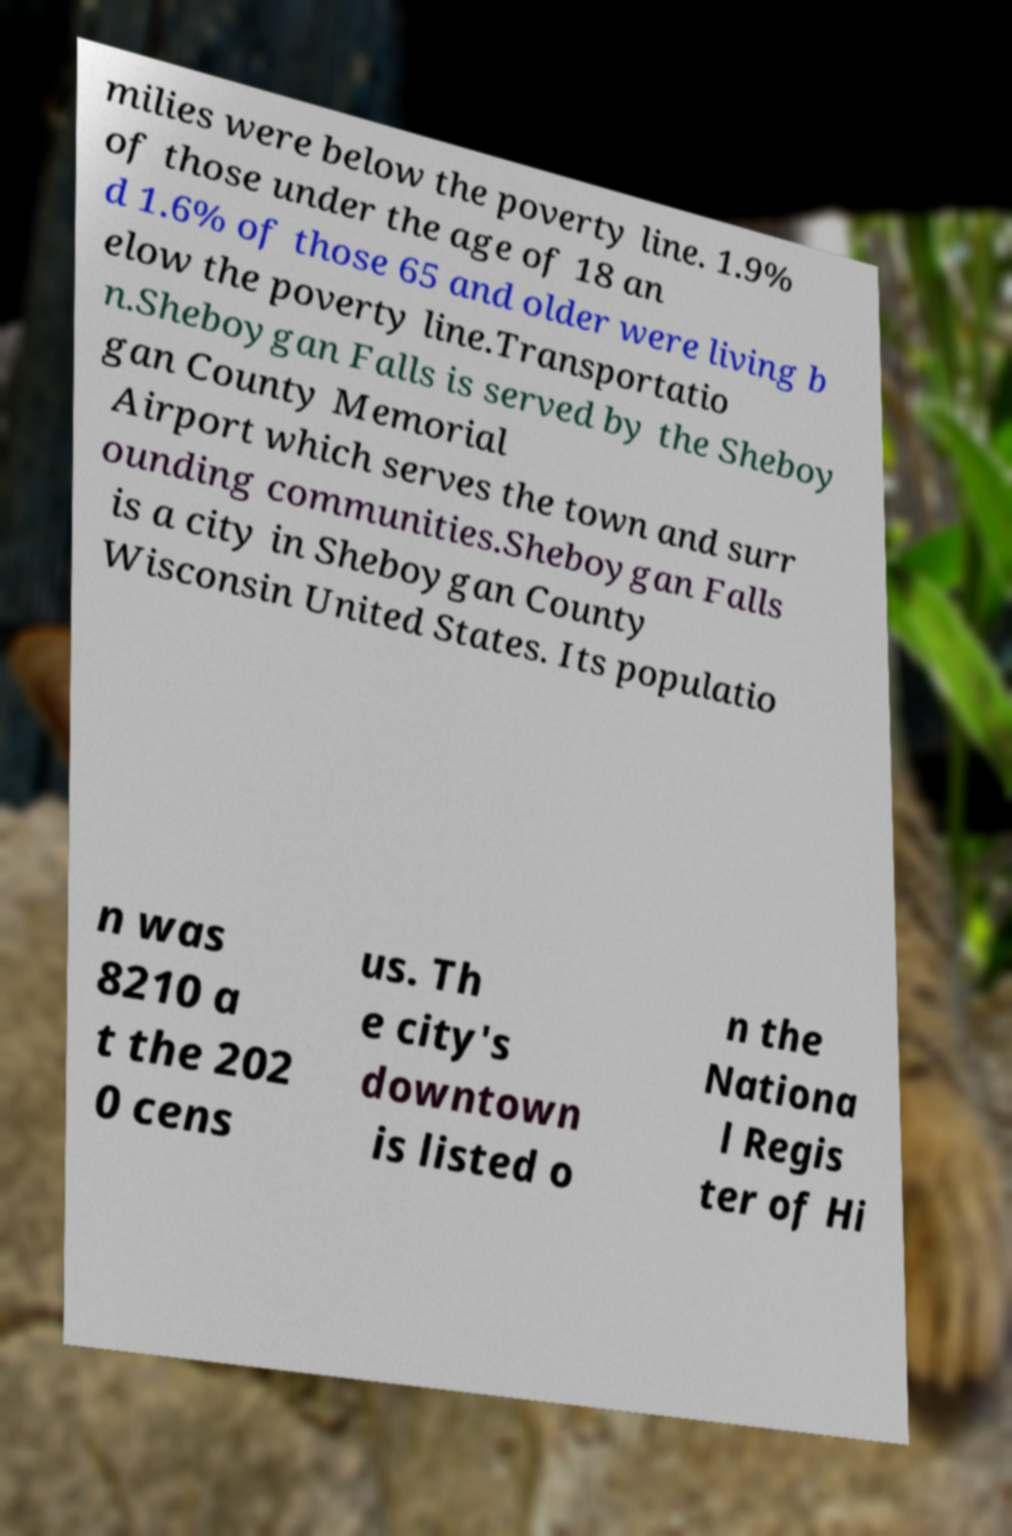I need the written content from this picture converted into text. Can you do that? milies were below the poverty line. 1.9% of those under the age of 18 an d 1.6% of those 65 and older were living b elow the poverty line.Transportatio n.Sheboygan Falls is served by the Sheboy gan County Memorial Airport which serves the town and surr ounding communities.Sheboygan Falls is a city in Sheboygan County Wisconsin United States. Its populatio n was 8210 a t the 202 0 cens us. Th e city's downtown is listed o n the Nationa l Regis ter of Hi 